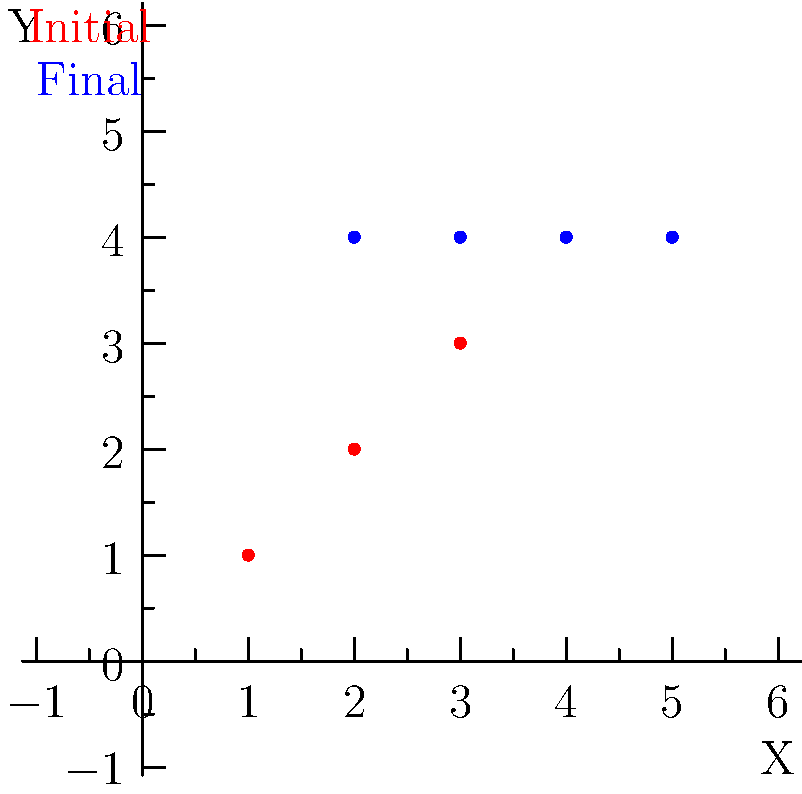A local football team in the Northern Mariana Islands is experimenting with a new formation. The diagram shows the initial (red) and final (blue) positions of four players on a coordinate system. If the average vertical displacement of the players is calculated as $\frac{\sum (y_{final} - y_{initial})}{n}$, where $n$ is the number of players, what is the average vertical displacement? To calculate the average vertical displacement, we need to follow these steps:

1. Identify the initial and final y-coordinates for each player:
   Player 1: $(1,1)$ to $(2,4)$
   Player 2: $(2,2)$ to $(3,4)$
   Player 3: $(3,3)$ to $(4,4)$
   Player 4: $(4,4)$ to $(5,4)$

2. Calculate the vertical displacement $(y_{final} - y_{initial})$ for each player:
   Player 1: $4 - 1 = 3$
   Player 2: $4 - 2 = 2$
   Player 3: $4 - 3 = 1$
   Player 4: $4 - 4 = 0$

3. Sum up all the vertical displacements:
   $3 + 2 + 1 + 0 = 6$

4. Divide by the number of players $(n = 4)$ to get the average:
   $\frac{6}{4} = 1.5$

Therefore, the average vertical displacement is 1.5 units.
Answer: 1.5 